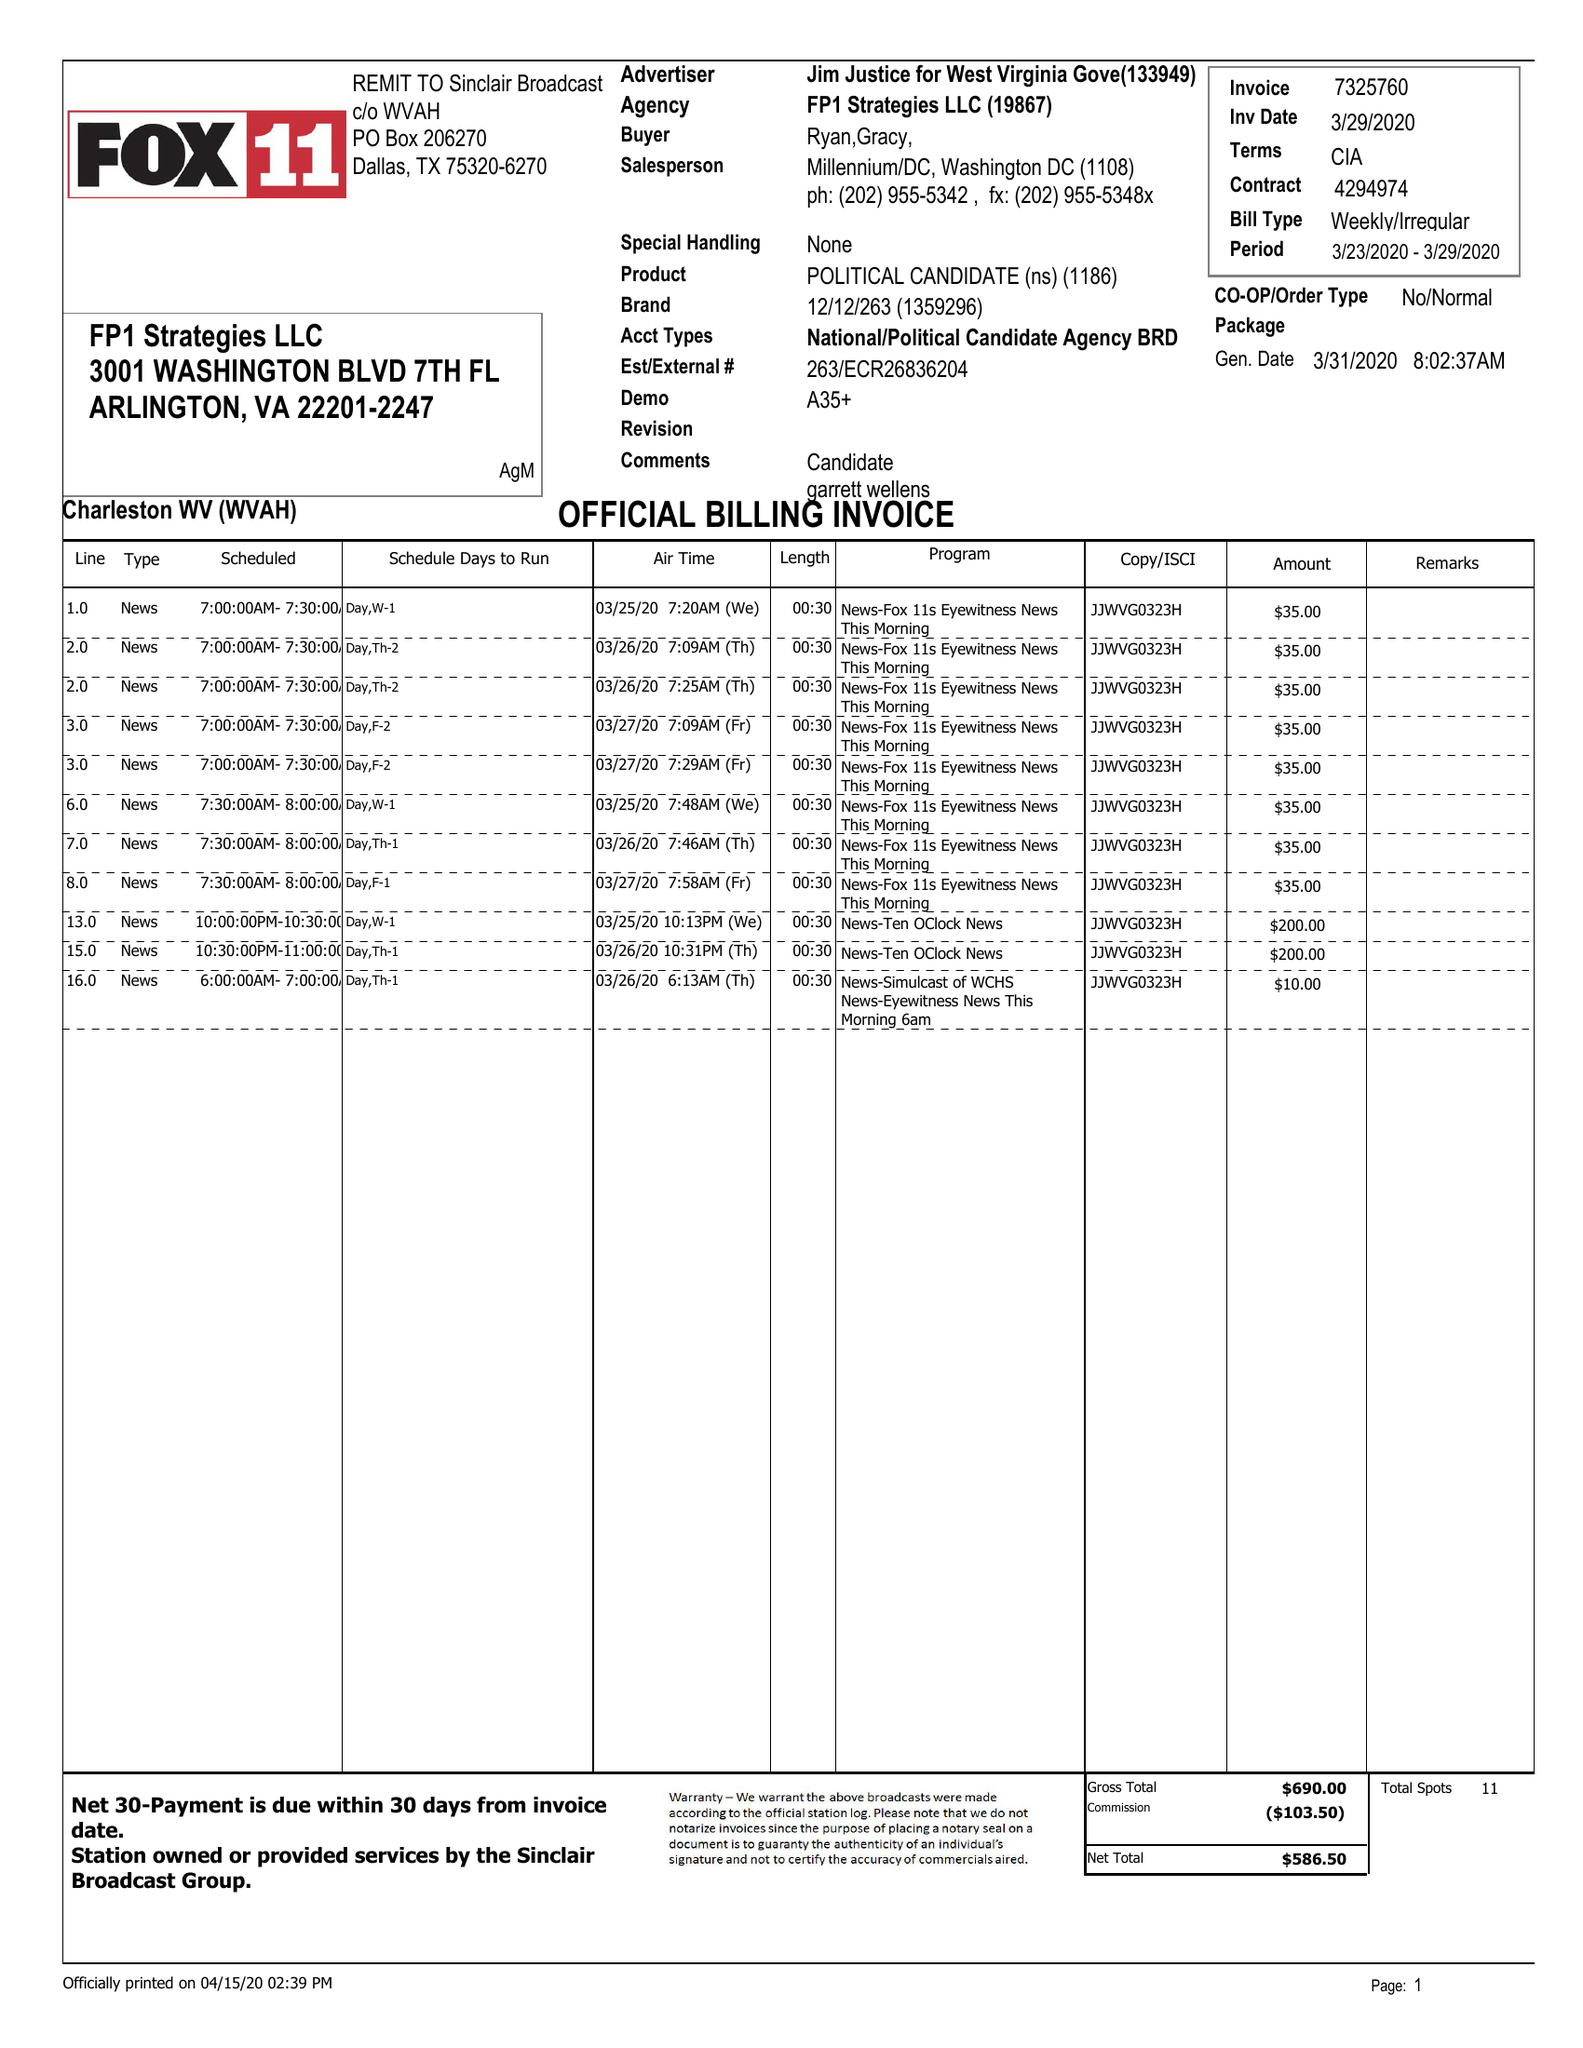What is the value for the flight_from?
Answer the question using a single word or phrase. 03/23/20 